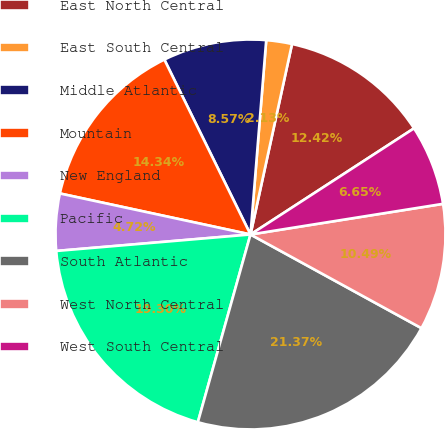Convert chart. <chart><loc_0><loc_0><loc_500><loc_500><pie_chart><fcel>East North Central<fcel>East South Central<fcel>Middle Atlantic<fcel>Mountain<fcel>New England<fcel>Pacific<fcel>South Atlantic<fcel>West North Central<fcel>West South Central<nl><fcel>12.42%<fcel>2.13%<fcel>8.57%<fcel>14.34%<fcel>4.72%<fcel>19.3%<fcel>21.37%<fcel>10.49%<fcel>6.65%<nl></chart> 